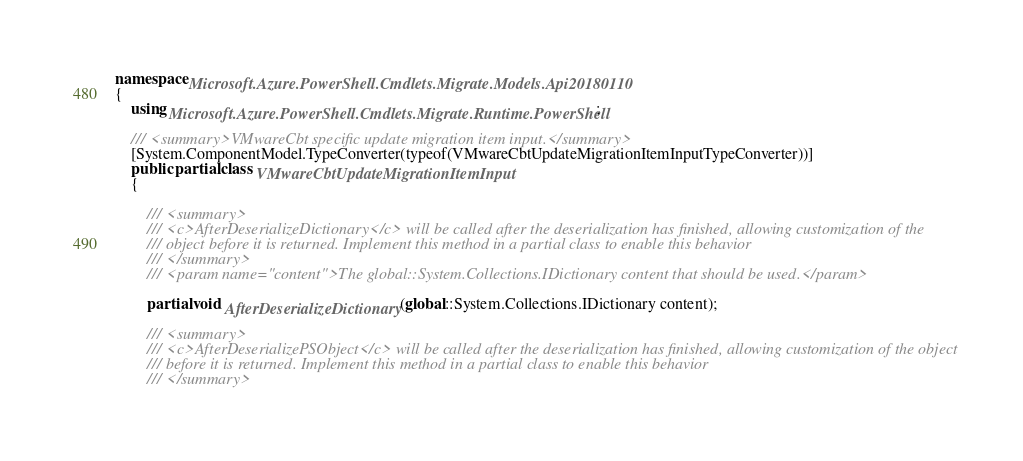Convert code to text. <code><loc_0><loc_0><loc_500><loc_500><_C#_>namespace Microsoft.Azure.PowerShell.Cmdlets.Migrate.Models.Api20180110
{
    using Microsoft.Azure.PowerShell.Cmdlets.Migrate.Runtime.PowerShell;

    /// <summary>VMwareCbt specific update migration item input.</summary>
    [System.ComponentModel.TypeConverter(typeof(VMwareCbtUpdateMigrationItemInputTypeConverter))]
    public partial class VMwareCbtUpdateMigrationItemInput
    {

        /// <summary>
        /// <c>AfterDeserializeDictionary</c> will be called after the deserialization has finished, allowing customization of the
        /// object before it is returned. Implement this method in a partial class to enable this behavior
        /// </summary>
        /// <param name="content">The global::System.Collections.IDictionary content that should be used.</param>

        partial void AfterDeserializeDictionary(global::System.Collections.IDictionary content);

        /// <summary>
        /// <c>AfterDeserializePSObject</c> will be called after the deserialization has finished, allowing customization of the object
        /// before it is returned. Implement this method in a partial class to enable this behavior
        /// </summary></code> 